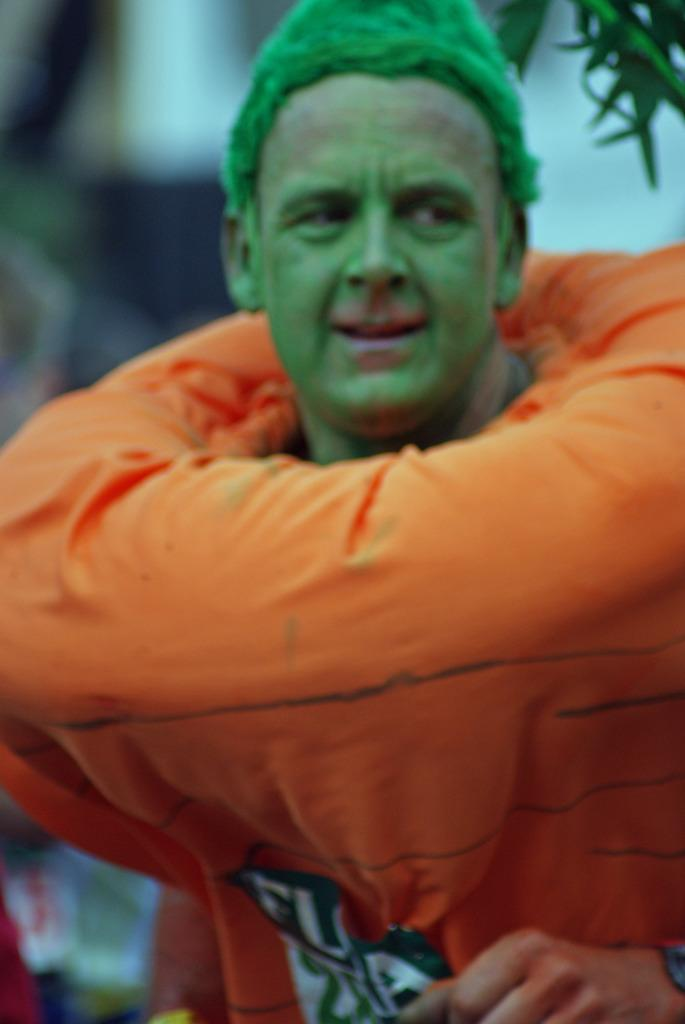Who or what is the main subject in the image? There is a person in the image. What can be seen in the top right corner of the image? There are leaves in the top right corner of the image. Can you describe the background of the image? The area behind the person is blurred. What type of kitty can be seen helping the fireman in the image? There is no kitty or fireman present in the image. 